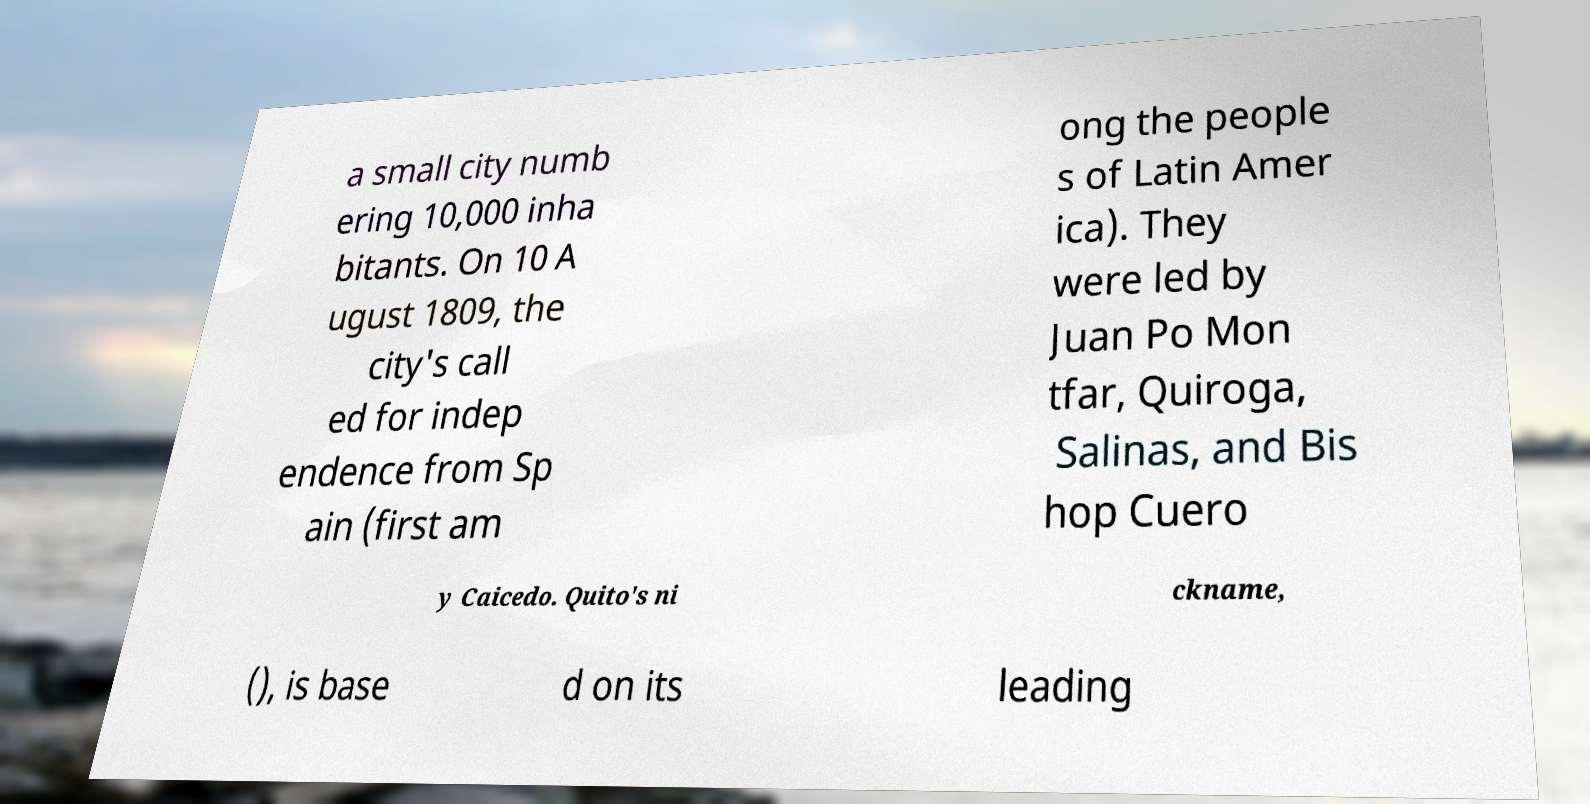Please read and relay the text visible in this image. What does it say? a small city numb ering 10,000 inha bitants. On 10 A ugust 1809, the city's call ed for indep endence from Sp ain (first am ong the people s of Latin Amer ica). They were led by Juan Po Mon tfar, Quiroga, Salinas, and Bis hop Cuero y Caicedo. Quito's ni ckname, (), is base d on its leading 